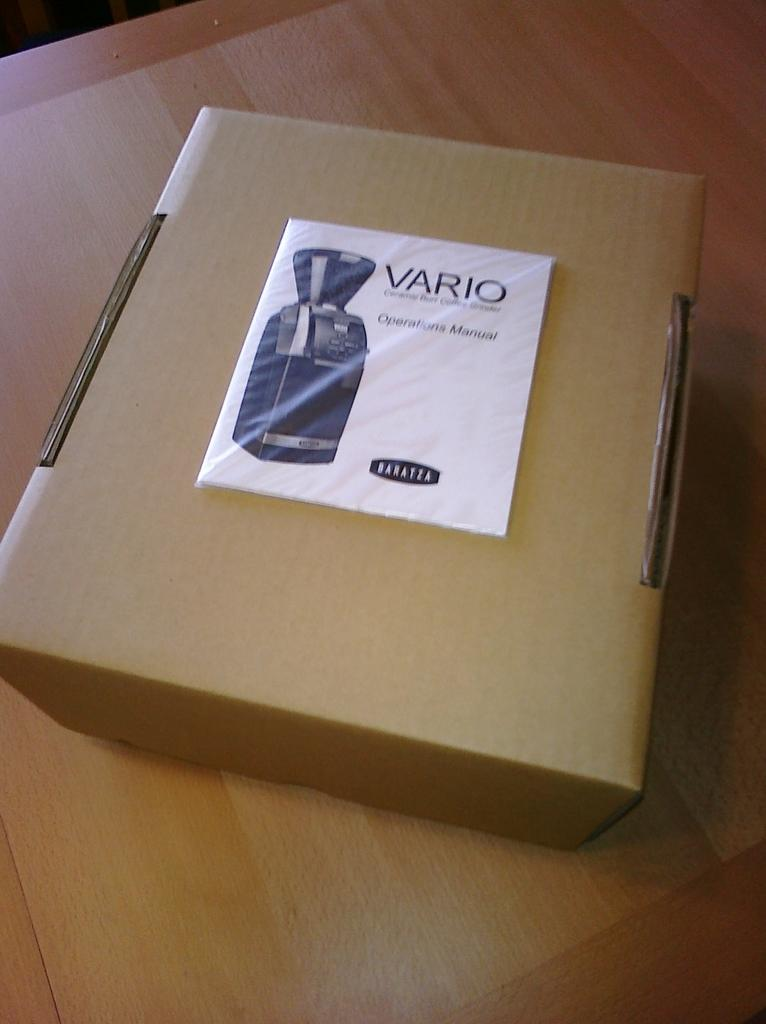<image>
Provide a brief description of the given image. A Vario box with an Operation Manual on top. 